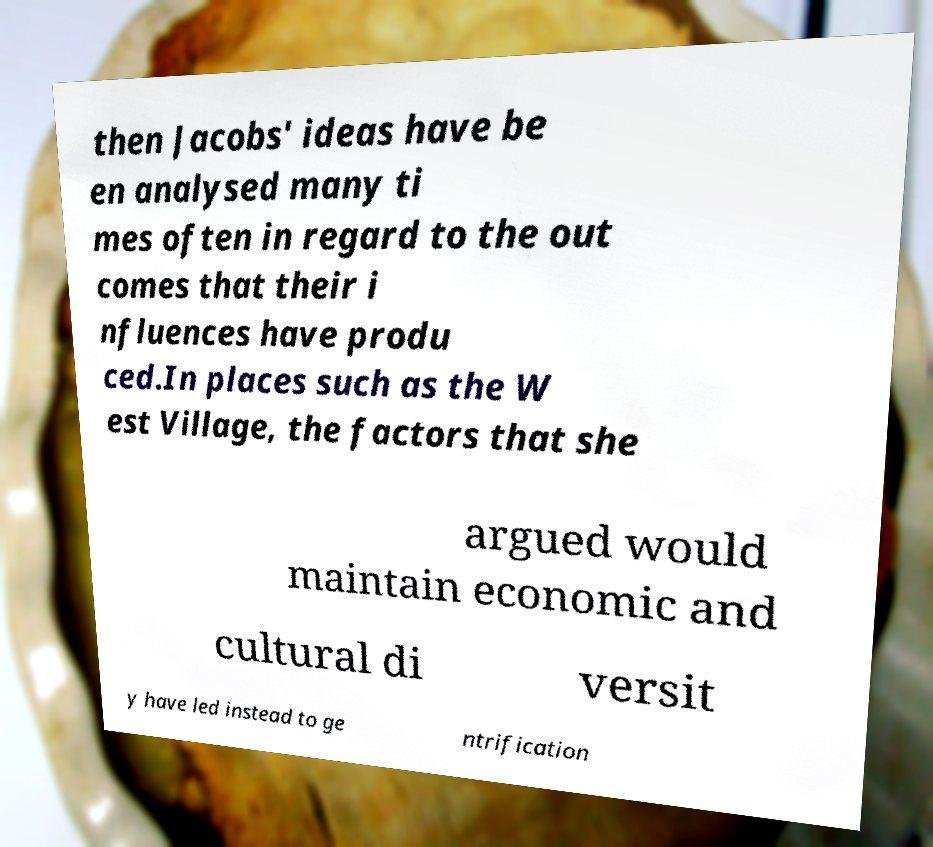Can you accurately transcribe the text from the provided image for me? then Jacobs' ideas have be en analysed many ti mes often in regard to the out comes that their i nfluences have produ ced.In places such as the W est Village, the factors that she argued would maintain economic and cultural di versit y have led instead to ge ntrification 